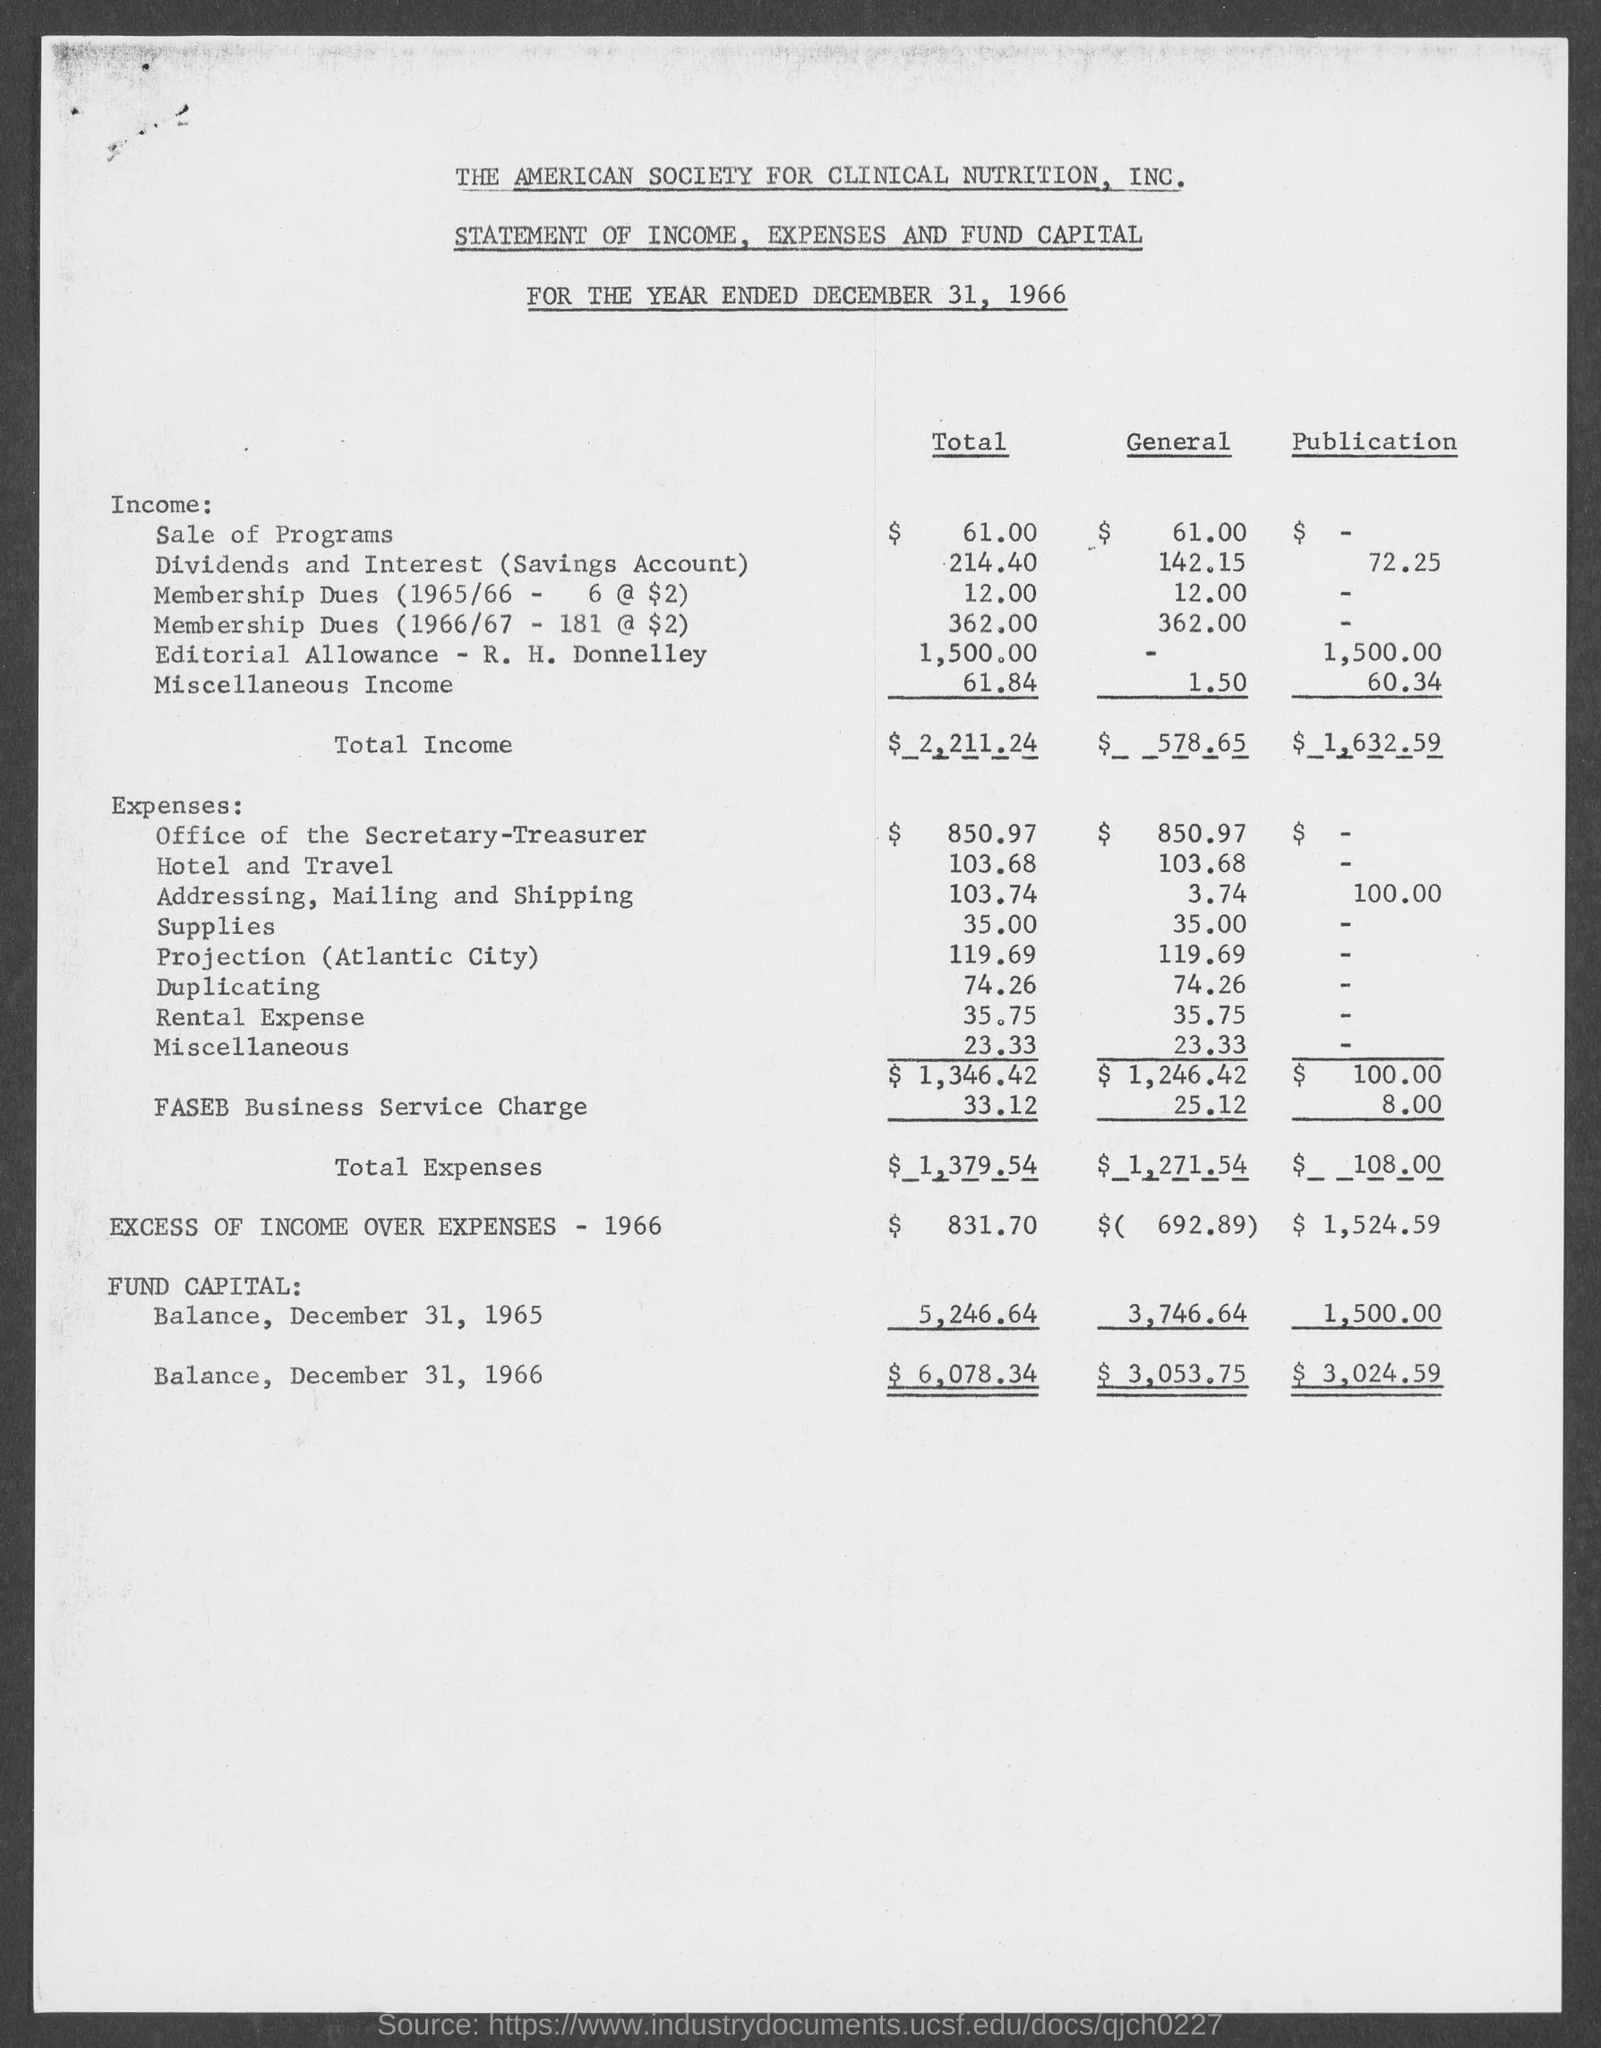Identify some key points in this picture. The total expenses for the publication were $108.00. The total capital balance of the fund as of December 31, 1965 was $5,246.64. The total income is $2,211.24. The total expense is $1,271.54. On December 31, 1966, the total fund capital balance was $6,078.34. 